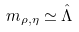Convert formula to latex. <formula><loc_0><loc_0><loc_500><loc_500>m _ { \rho , \eta } \simeq \hat { \Lambda }</formula> 